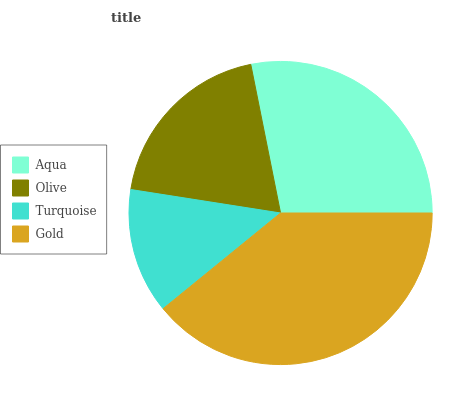Is Turquoise the minimum?
Answer yes or no. Yes. Is Gold the maximum?
Answer yes or no. Yes. Is Olive the minimum?
Answer yes or no. No. Is Olive the maximum?
Answer yes or no. No. Is Aqua greater than Olive?
Answer yes or no. Yes. Is Olive less than Aqua?
Answer yes or no. Yes. Is Olive greater than Aqua?
Answer yes or no. No. Is Aqua less than Olive?
Answer yes or no. No. Is Aqua the high median?
Answer yes or no. Yes. Is Olive the low median?
Answer yes or no. Yes. Is Turquoise the high median?
Answer yes or no. No. Is Turquoise the low median?
Answer yes or no. No. 